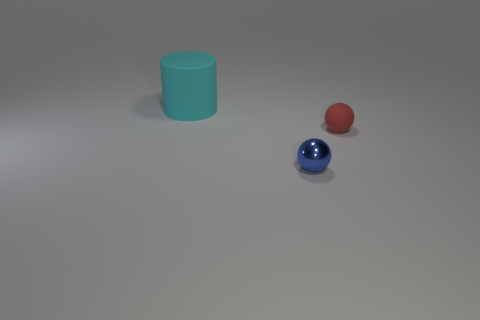How many other things have the same size as the blue metallic thing?
Ensure brevity in your answer.  1. Is the material of the object behind the tiny matte object the same as the thing that is right of the small blue object?
Provide a succinct answer. Yes. What is the material of the object behind the matte thing on the right side of the cylinder?
Your response must be concise. Rubber. There is a thing behind the rubber sphere; what is it made of?
Make the answer very short. Rubber. What number of tiny blue metal things are the same shape as the red rubber object?
Ensure brevity in your answer.  1. There is a small thing in front of the small thing that is to the right of the tiny object that is on the left side of the tiny red rubber ball; what is it made of?
Keep it short and to the point. Metal. There is a shiny object; are there any small things to the right of it?
Your answer should be very brief. Yes. Do the cylinder and the blue ball have the same material?
Make the answer very short. No. How many metallic things are tiny red things or cyan objects?
Your response must be concise. 0. The thing in front of the rubber object that is in front of the large cyan rubber object is what shape?
Make the answer very short. Sphere. 